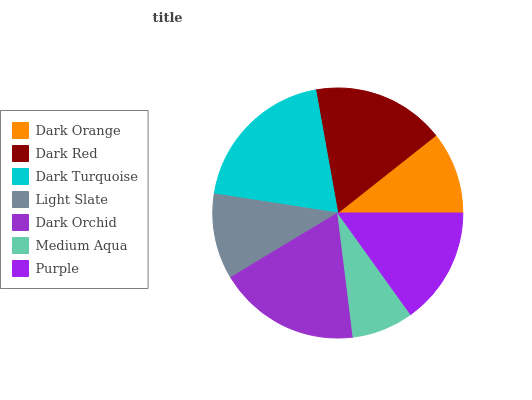Is Medium Aqua the minimum?
Answer yes or no. Yes. Is Dark Turquoise the maximum?
Answer yes or no. Yes. Is Dark Red the minimum?
Answer yes or no. No. Is Dark Red the maximum?
Answer yes or no. No. Is Dark Red greater than Dark Orange?
Answer yes or no. Yes. Is Dark Orange less than Dark Red?
Answer yes or no. Yes. Is Dark Orange greater than Dark Red?
Answer yes or no. No. Is Dark Red less than Dark Orange?
Answer yes or no. No. Is Purple the high median?
Answer yes or no. Yes. Is Purple the low median?
Answer yes or no. Yes. Is Dark Orange the high median?
Answer yes or no. No. Is Medium Aqua the low median?
Answer yes or no. No. 